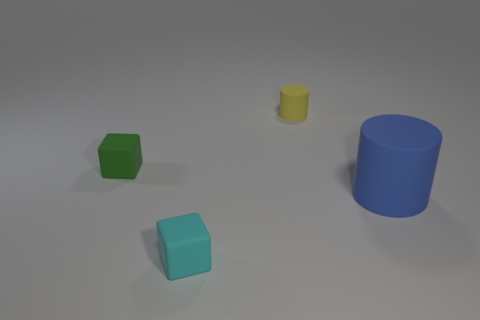Are there fewer green rubber cubes than green metal things?
Your answer should be very brief. No. Are there any other things that have the same color as the large rubber cylinder?
Offer a very short reply. No. What is the shape of the thing that is in front of the blue matte cylinder?
Provide a succinct answer. Cube. There is a tiny cylinder; does it have the same color as the cylinder in front of the green object?
Provide a short and direct response. No. Are there an equal number of big matte things in front of the blue matte object and big blue matte objects in front of the tiny cylinder?
Give a very brief answer. No. What number of other objects are there of the same size as the cyan object?
Your response must be concise. 2. What size is the blue rubber cylinder?
Keep it short and to the point. Large. Does the green cube have the same material as the small yellow thing that is to the right of the tiny cyan thing?
Your answer should be very brief. Yes. Is there another tiny cyan matte object of the same shape as the cyan object?
Offer a terse response. No. There is a yellow object that is the same size as the green thing; what is its material?
Your answer should be compact. Rubber. 